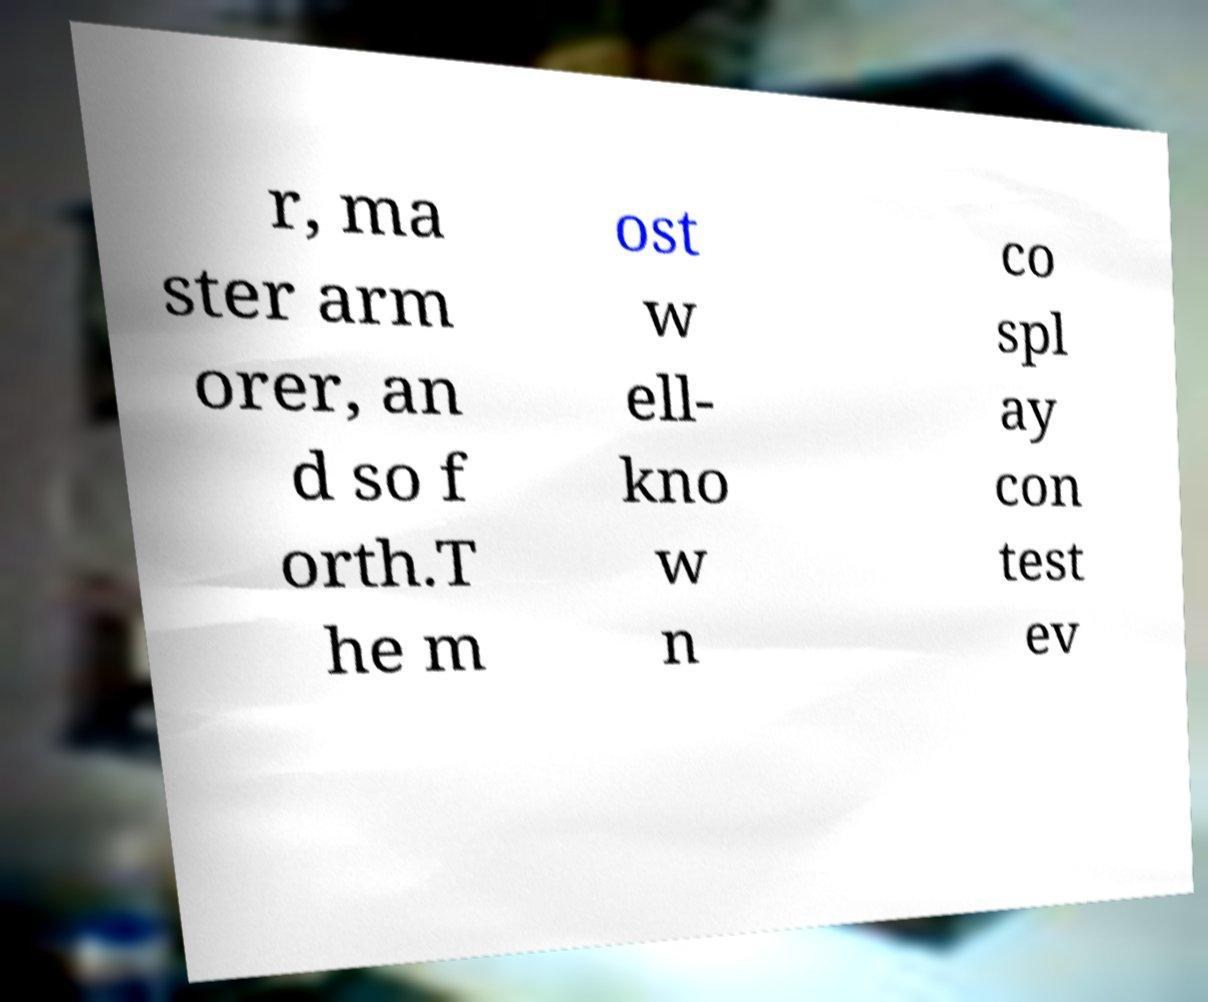For documentation purposes, I need the text within this image transcribed. Could you provide that? r, ma ster arm orer, an d so f orth.T he m ost w ell- kno w n co spl ay con test ev 